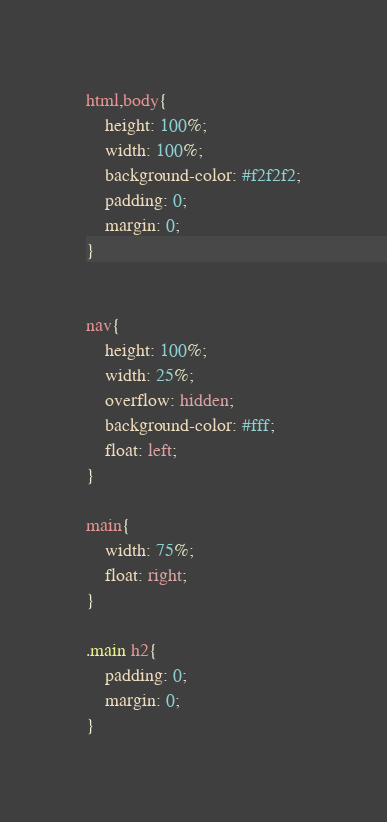<code> <loc_0><loc_0><loc_500><loc_500><_CSS_>html,body{
	height: 100%;
	width: 100%;
	background-color: #f2f2f2;
	padding: 0;
	margin: 0;
}


nav{
	height: 100%;
	width: 25%;
	overflow: hidden;
	background-color: #fff;
	float: left;
}

main{
	width: 75%;
	float: right;
}

.main h2{
	padding: 0;
	margin: 0;	
}
</code> 